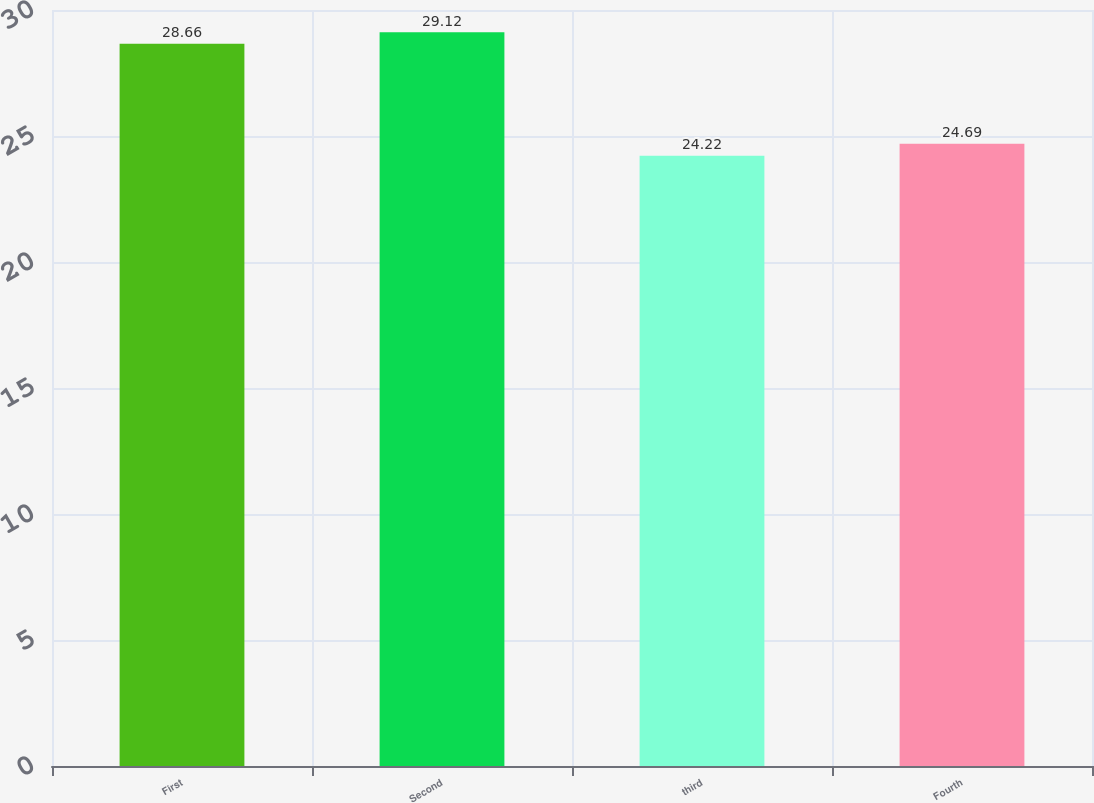<chart> <loc_0><loc_0><loc_500><loc_500><bar_chart><fcel>First<fcel>Second<fcel>third<fcel>Fourth<nl><fcel>28.66<fcel>29.12<fcel>24.22<fcel>24.69<nl></chart> 